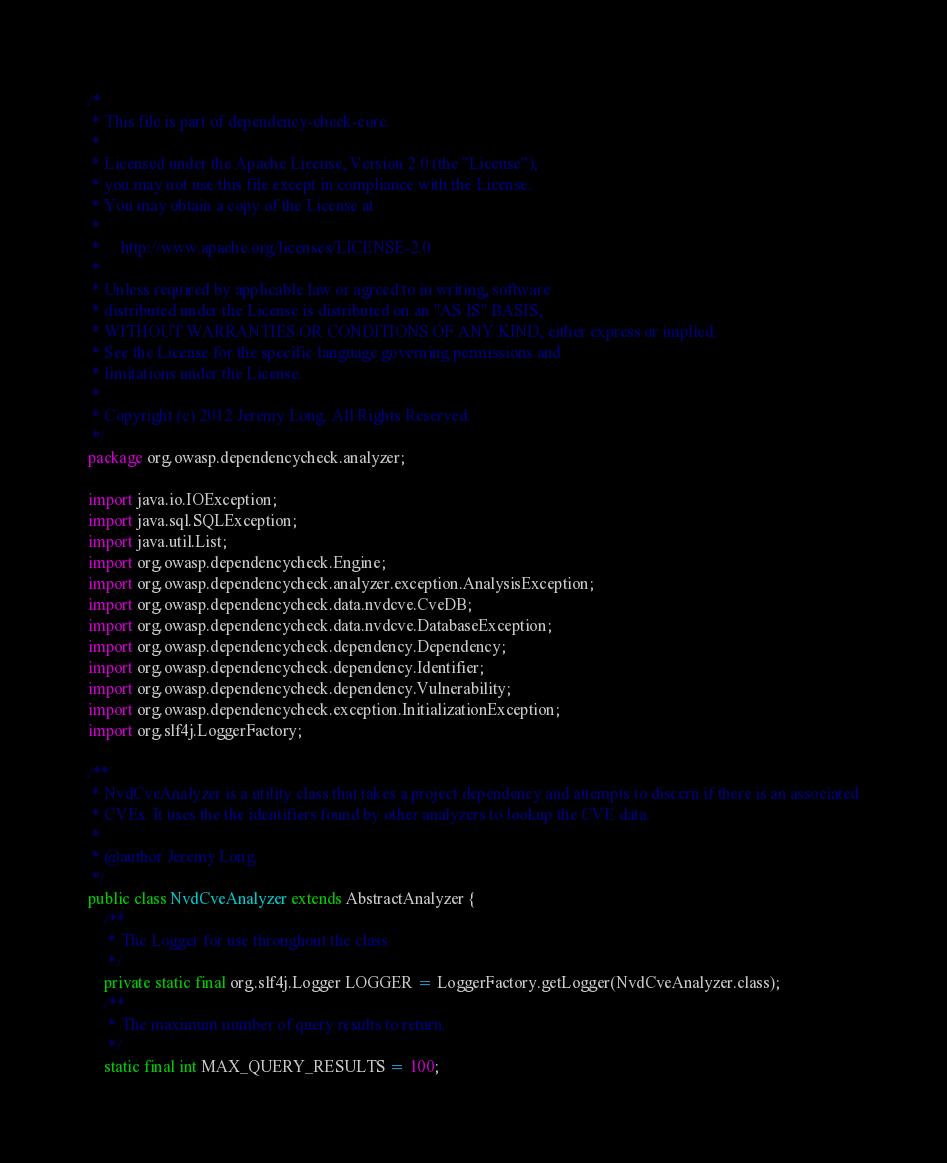Convert code to text. <code><loc_0><loc_0><loc_500><loc_500><_Java_>/*
 * This file is part of dependency-check-core.
 *
 * Licensed under the Apache License, Version 2.0 (the "License");
 * you may not use this file except in compliance with the License.
 * You may obtain a copy of the License at
 *
 *     http://www.apache.org/licenses/LICENSE-2.0
 *
 * Unless required by applicable law or agreed to in writing, software
 * distributed under the License is distributed on an "AS IS" BASIS,
 * WITHOUT WARRANTIES OR CONDITIONS OF ANY KIND, either express or implied.
 * See the License for the specific language governing permissions and
 * limitations under the License.
 *
 * Copyright (c) 2012 Jeremy Long. All Rights Reserved.
 */
package org.owasp.dependencycheck.analyzer;

import java.io.IOException;
import java.sql.SQLException;
import java.util.List;
import org.owasp.dependencycheck.Engine;
import org.owasp.dependencycheck.analyzer.exception.AnalysisException;
import org.owasp.dependencycheck.data.nvdcve.CveDB;
import org.owasp.dependencycheck.data.nvdcve.DatabaseException;
import org.owasp.dependencycheck.dependency.Dependency;
import org.owasp.dependencycheck.dependency.Identifier;
import org.owasp.dependencycheck.dependency.Vulnerability;
import org.owasp.dependencycheck.exception.InitializationException;
import org.slf4j.LoggerFactory;

/**
 * NvdCveAnalyzer is a utility class that takes a project dependency and attempts to discern if there is an associated
 * CVEs. It uses the the identifiers found by other analyzers to lookup the CVE data.
 *
 * @author Jeremy Long
 */
public class NvdCveAnalyzer extends AbstractAnalyzer {
    /**
     * The Logger for use throughout the class
     */
    private static final org.slf4j.Logger LOGGER = LoggerFactory.getLogger(NvdCveAnalyzer.class);
    /**
     * The maximum number of query results to return.
     */
    static final int MAX_QUERY_RESULTS = 100;</code> 